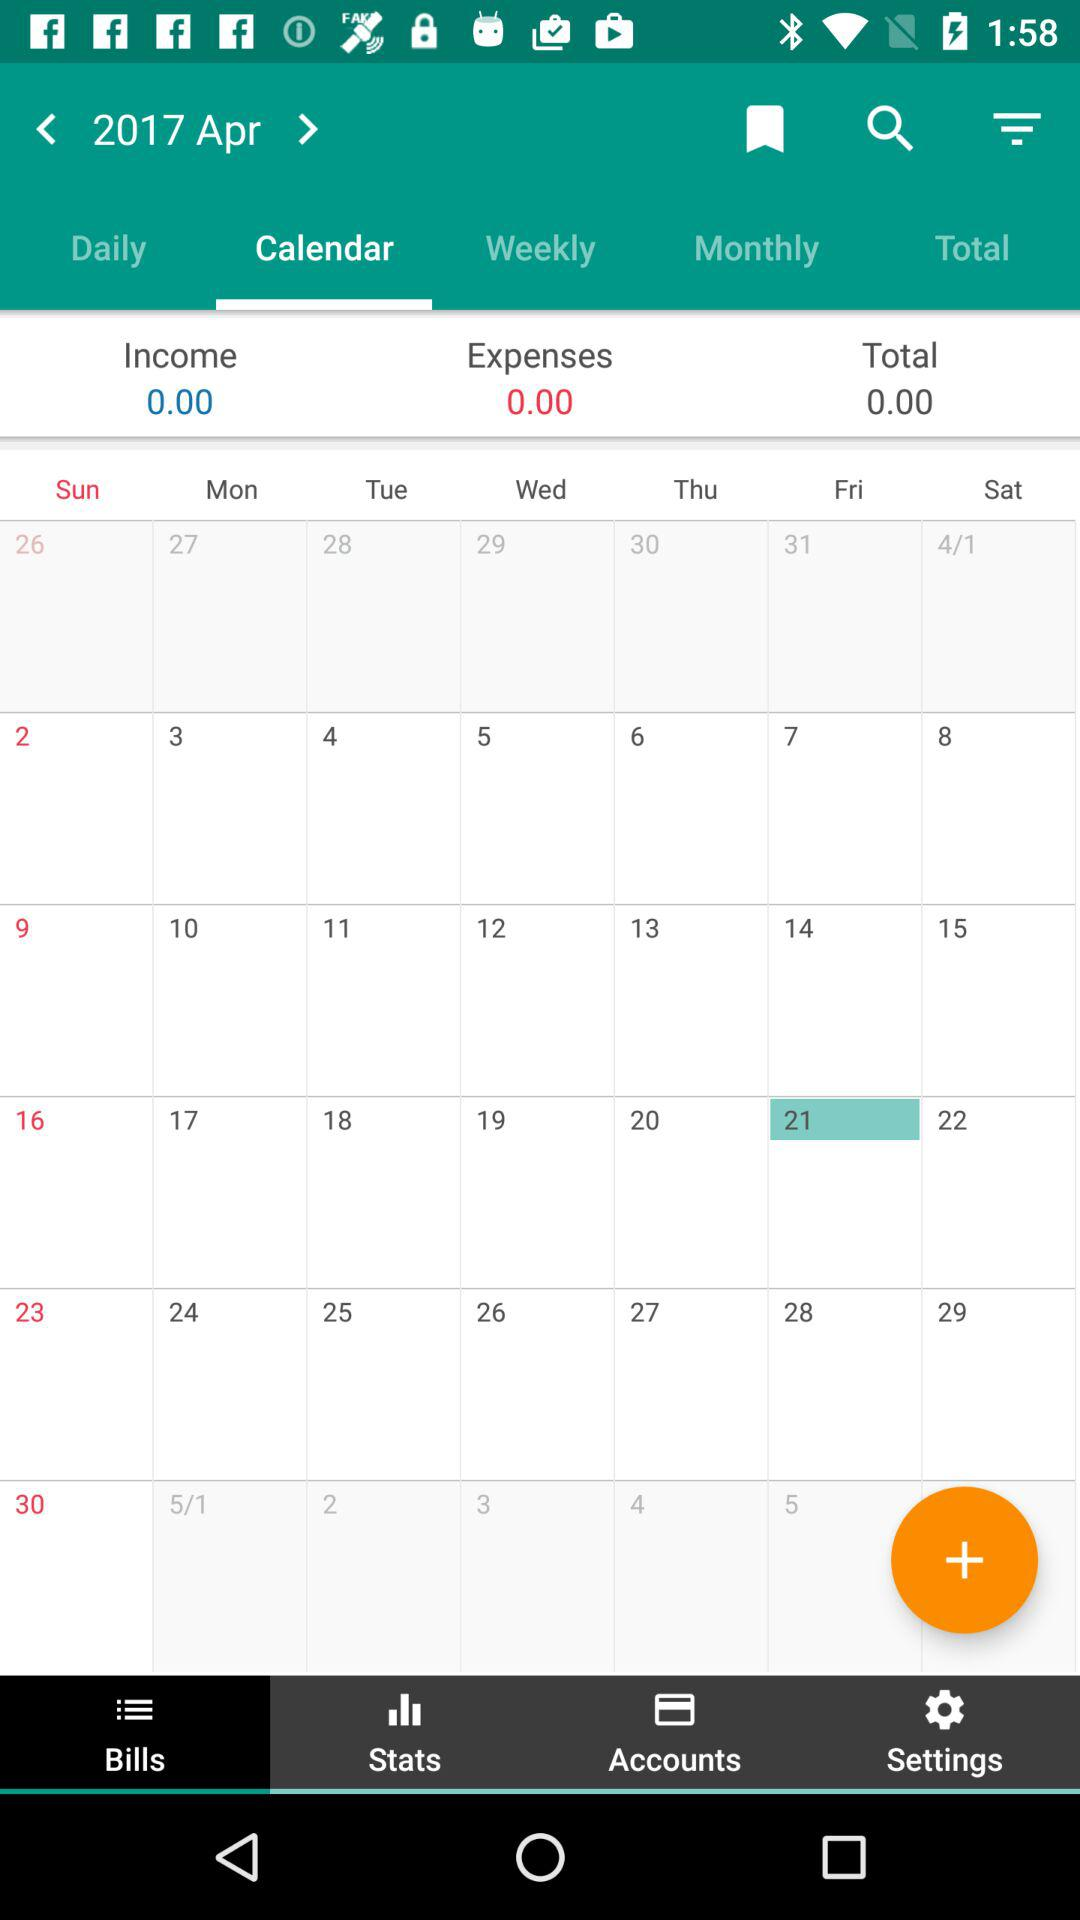What is the total amount in the "Calendar"? The total amount in the "Calendar" is 0. 